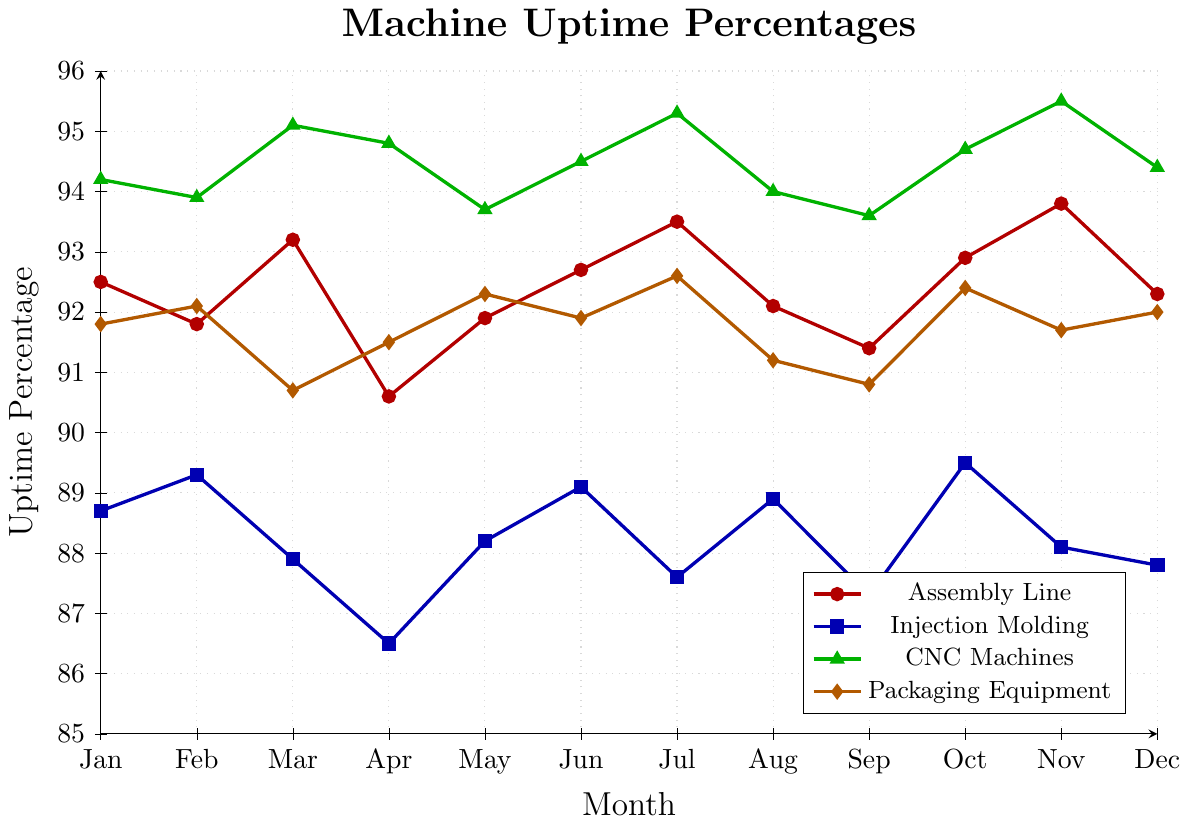Which month has the highest uptime percentage for CNC Machines? Look at the line representing CNC Machines, which is depicted in green. The highest point on this line occurs in November with a value of 95.5%.
Answer: November Which machine had the lowest uptime percentage in April? Observe the lines corresponding to April. Injection Molding, represented by the blue line, has the lowest value at 86.5%.
Answer: Injection Molding What is the average uptime percentage of the Assembly Line over the entire year? Sum the values for Assembly Line across each month and divide by 12. The sum is (92.5 + 91.8 + 93.2 + 90.6 + 91.9 + 92.7 + 93.5 + 92.1 + 91.4 + 92.9 + 93.8 + 92.3) = 1128.7. The average is 1128.7 / 12 ≈ 94.1.
Answer: 94.1 During which month did the Injection Molding and Packaging Equipment have nearly identical uptime percentages? Compare the lines for Injection Molding (blue) and Packaging Equipment (orange). In October, both values are close, with Injection Molding at 89.5% and Packaging Equipment at 92.4%.
Answer: October Which equipment had the most stable uptime percentage (least variation) throughout the year? Visually inspect the fluctuation of each line. The CNC Machines (green line) shows the least variation compared to others, remaining largely in the 93.6–95.5% range.
Answer: CNC Machines How many months did the Injection Molding machine have an uptime percentage below 88%? Check the values for Injection Molding (blue line). The machine had an uptime percentage below 88% in March (87.9%), April (86.5%), July (87.6%), August (88.9%) and September (87.3%).
Answer: 5 Which machine saw the biggest increase in uptime percentage between two consecutive months? Identify the largest difference by visual inspection and calculations. The biggest increase is from April (86.5%) to May (88.2%) for Injection Molding (blue line), an increase of 1.7%.
Answer: Injection Molding What's the difference in uptime percentage between the CNC Machines and Packaging Equipment in December? In December, the CNC Machines (green line) uptime is 94.4% and Packaging Equipment (orange line) uptime is 92.0%. The difference is 94.4% - 92.0% = 2.4%.
Answer: 2.4% Which month had the closest uptime percentages for all equipment types? Compare all lines to find the month where the values are the closest. In January, uptimes are Assembly Line (92.5%), Injection Molding (88.7%), CNC Machines (94.2%), Packaging Equipment (91.8%). The differences are relatively smaller.
Answer: January 